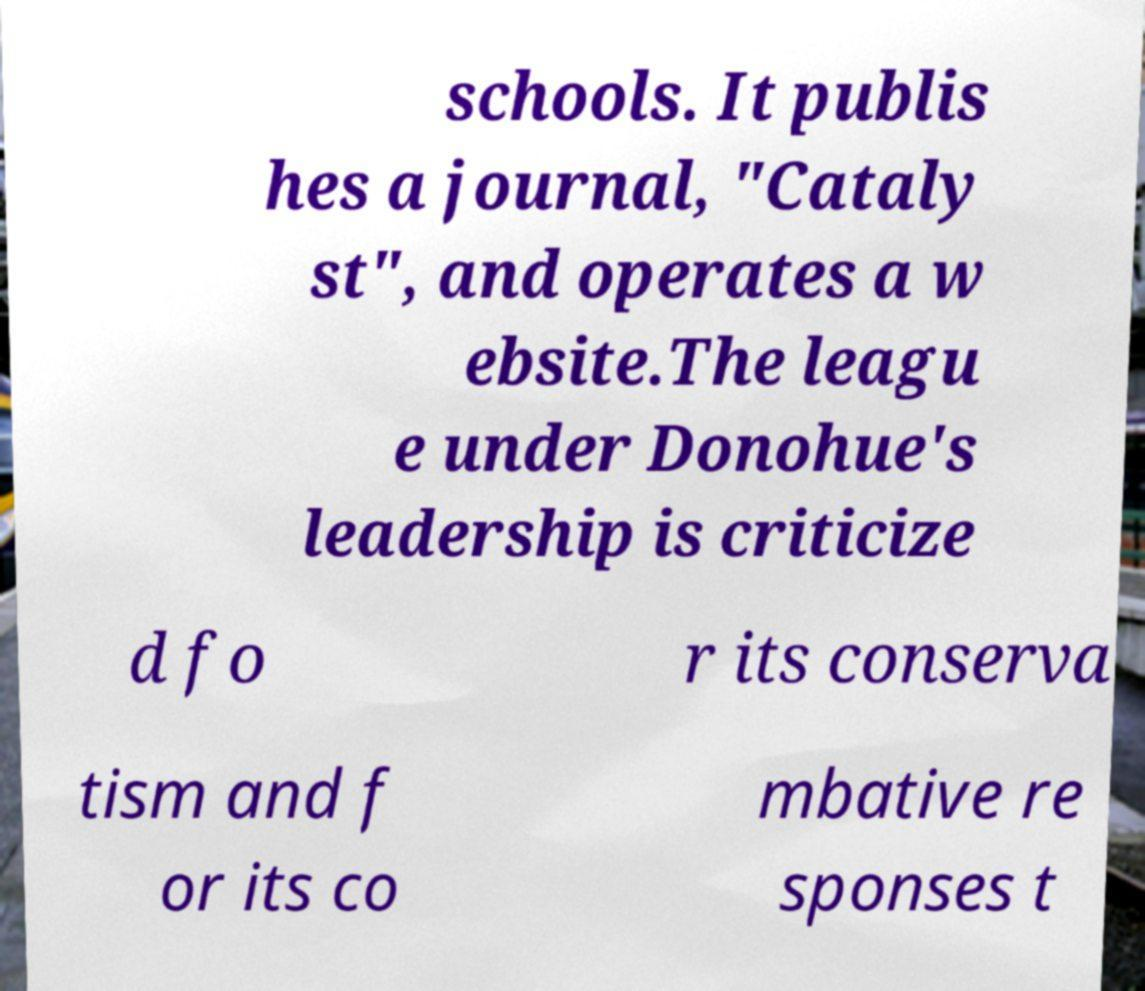Can you read and provide the text displayed in the image?This photo seems to have some interesting text. Can you extract and type it out for me? schools. It publis hes a journal, "Cataly st", and operates a w ebsite.The leagu e under Donohue's leadership is criticize d fo r its conserva tism and f or its co mbative re sponses t 